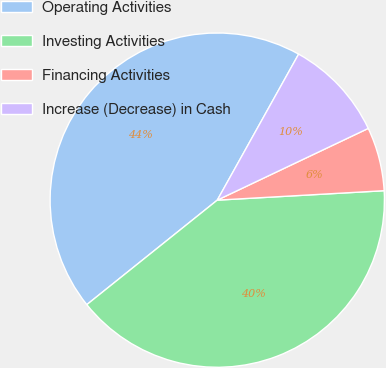Convert chart. <chart><loc_0><loc_0><loc_500><loc_500><pie_chart><fcel>Operating Activities<fcel>Investing Activities<fcel>Financing Activities<fcel>Increase (Decrease) in Cash<nl><fcel>43.84%<fcel>40.15%<fcel>6.16%<fcel>9.85%<nl></chart> 